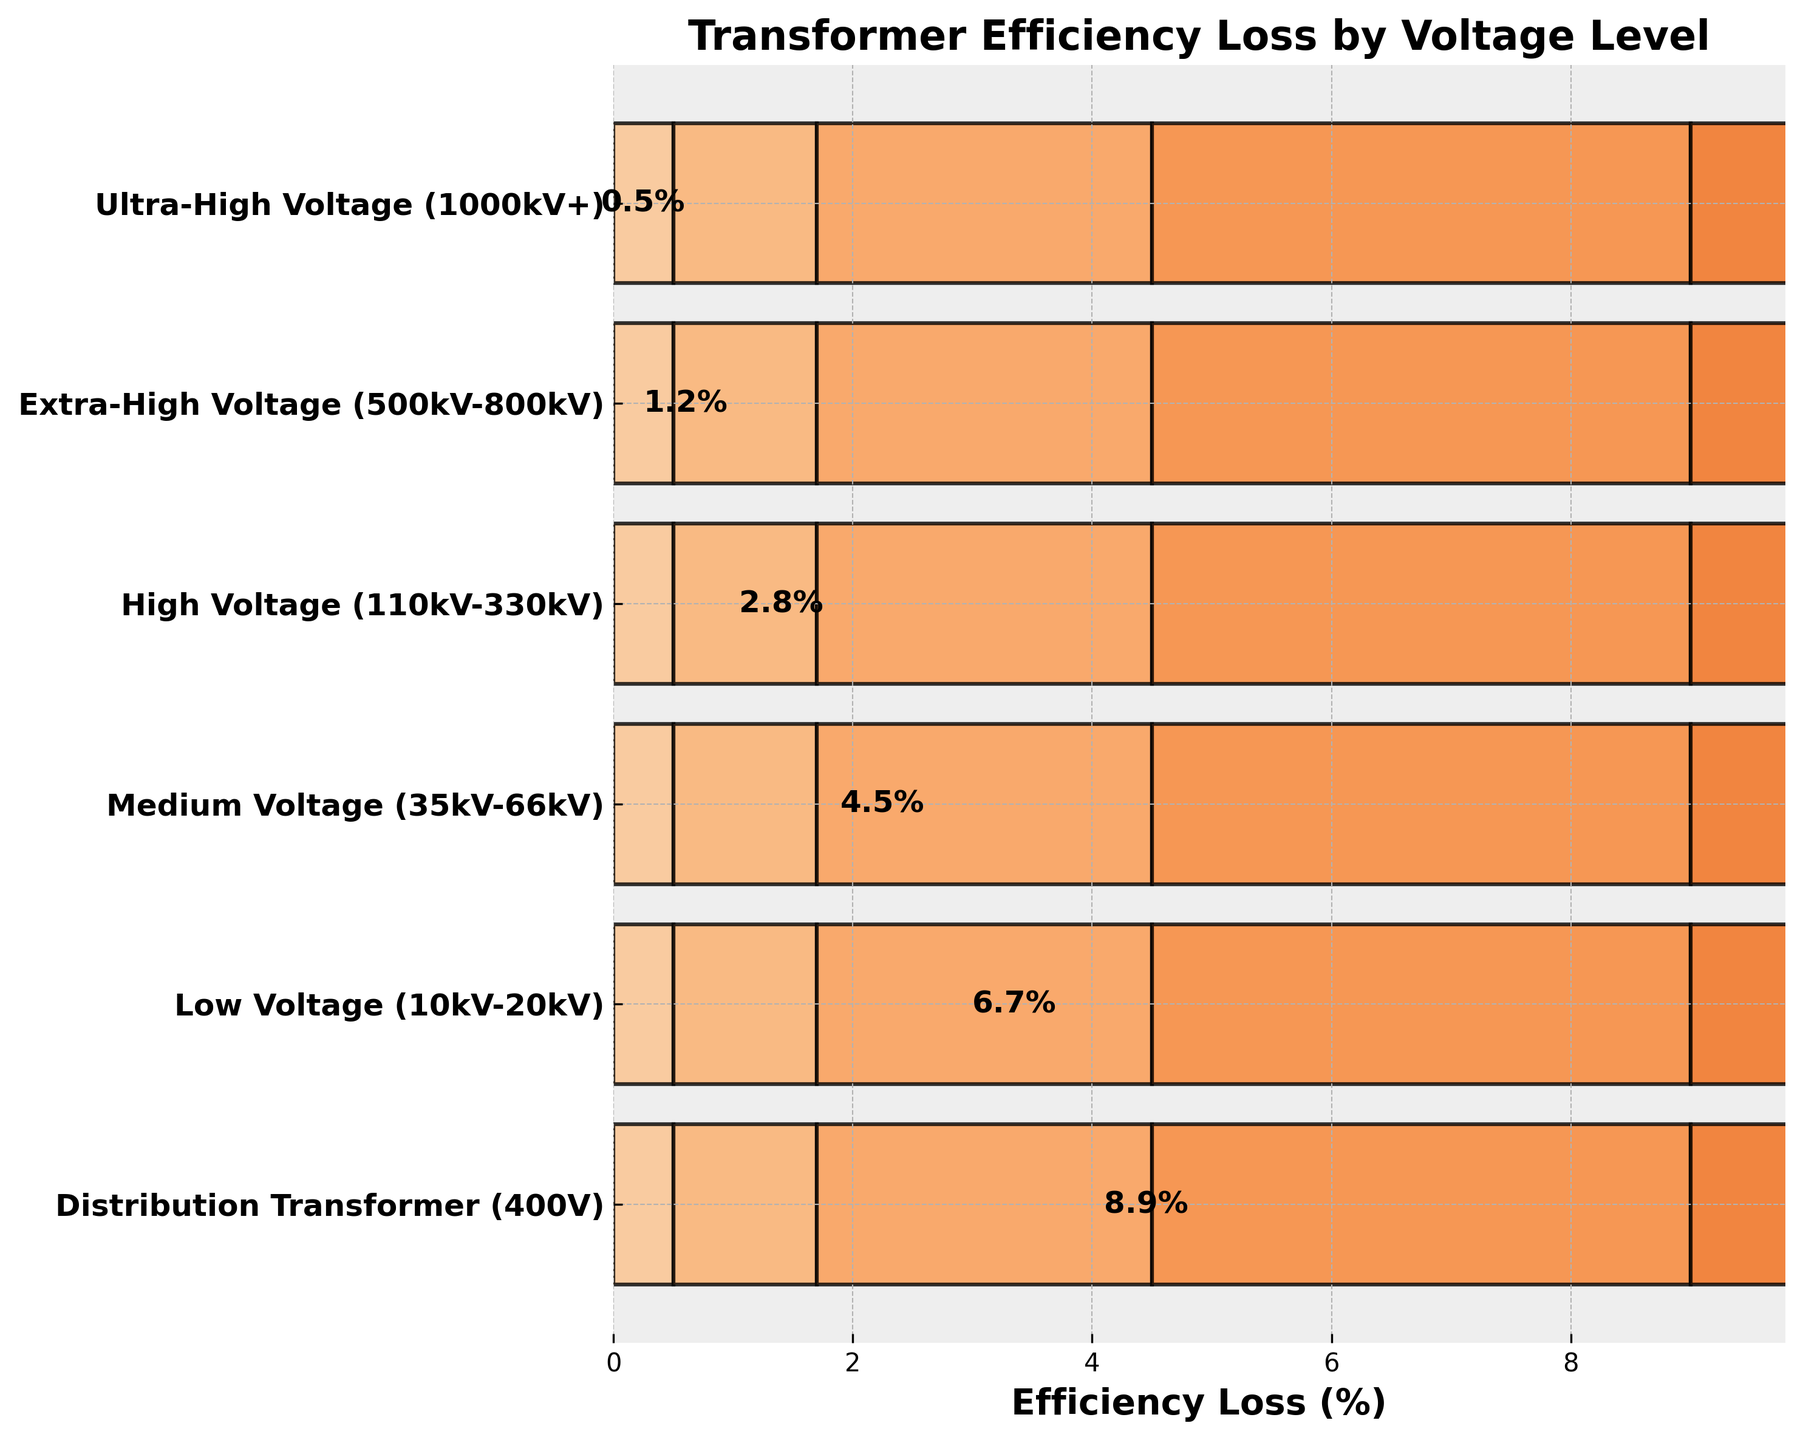What's the efficiency loss at the Extra-High Voltage level? The Extra-High Voltage level is labeled on the y-axis. The efficiency loss percentage next to it is 1.2%.
Answer: 1.2% Which voltage level has the highest efficiency loss? By observing the chart, the bar for the Distribution Transformer (400V) level is the longest, indicating the highest efficiency loss.
Answer: Distribution Transformer (400V) Compare the efficiency loss between High Voltage and Medium Voltage levels. Which one is greater, and by how much? The High Voltage level has an efficiency loss of 2.8%, while the Medium Voltage level has 4.5%. To find the difference, subtract 2.8 from 4.5.
Answer: Medium Voltage, 1.7% What is the combined efficiency loss for Ultra-High Voltage and Low Voltage levels? The efficiency loss for Ultra-High Voltage is 0.5%, and for Low Voltage, it is 6.7%. Adding them gives 0.5 + 6.7.
Answer: 7.2% How many voltage levels are displayed in the funnel chart? Count the different labels on the y-axis. There are 6 voltage levels listed.
Answer: 6 What is the average efficiency loss across all voltage levels? Sum all the efficiency loss percentages and divide by the number of voltage levels. (0.5 + 1.2 + 2.8 + 4.5 + 6.7 + 8.9) / 6 = 24.6 / 6
Answer: 4.1% Which two voltage levels have the smallest difference in efficiency loss, and what is that difference? The smallest difference can be found by comparing the differences between consecutive efficiency losses. The closest losses are 6.7% (Low Voltage) and 4.5% (Medium Voltage), with a difference of 6.7 - 4.5 = 2.2%.
Answer: Medium Voltage and Low Voltage, 2.2% What is the efficiency loss at the High Voltage level as a percentage of the total efficiency loss across all levels? First, calculate the total efficiency loss (0.5 + 1.2 + 2.8 + 4.5 + 6.7 + 8.9 = 24.6). The efficiency loss at High Voltage is 2.8%. The percentage is (2.8 / 24.6) * 100.
Answer: 11.4% What is the sum of the efficiency losses for Ultra-High Voltage, Extra-High Voltage, and High Voltage levels? Add the efficiency losses for Ultra-High Voltage (0.5%), Extra-High Voltage (1.2%), and High Voltage (2.8%). 0.5 + 1.2 + 2.8 = 4.5
Answer: 4.5% What is the efficiency loss difference between the lowest voltage level and the highest voltage level? The lowest voltage level is Distribution Transformer (400V) with an efficiency loss of 8.9%, and the highest voltage level is Ultra-High Voltage (1000kV+) with a loss of 0.5%. The difference is 8.9 - 0.5.
Answer: 8.4% 